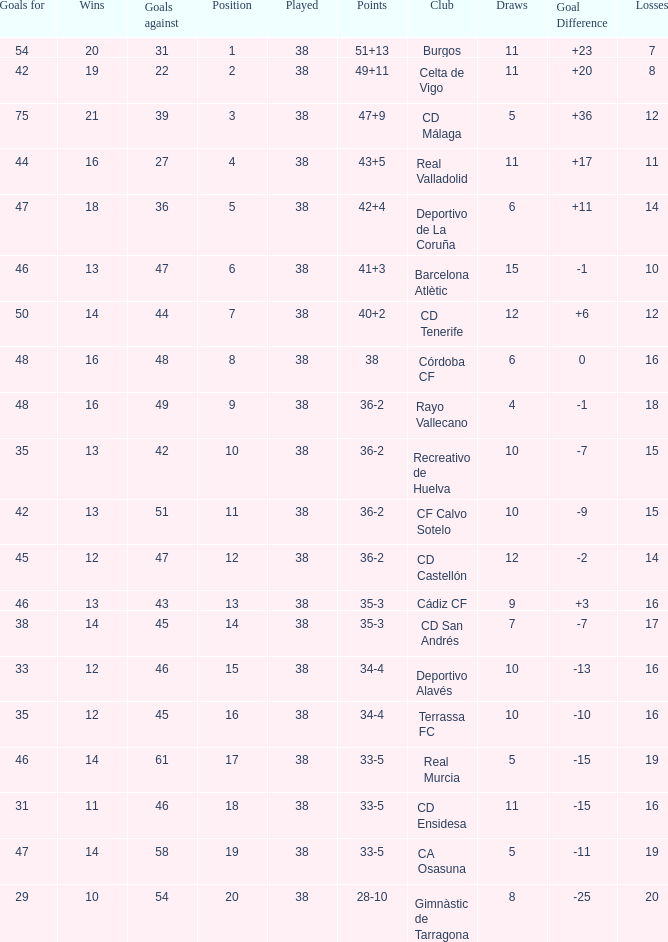How many positions have 14 wins, goals against of 61 and fewer than 19 losses? 0.0. 